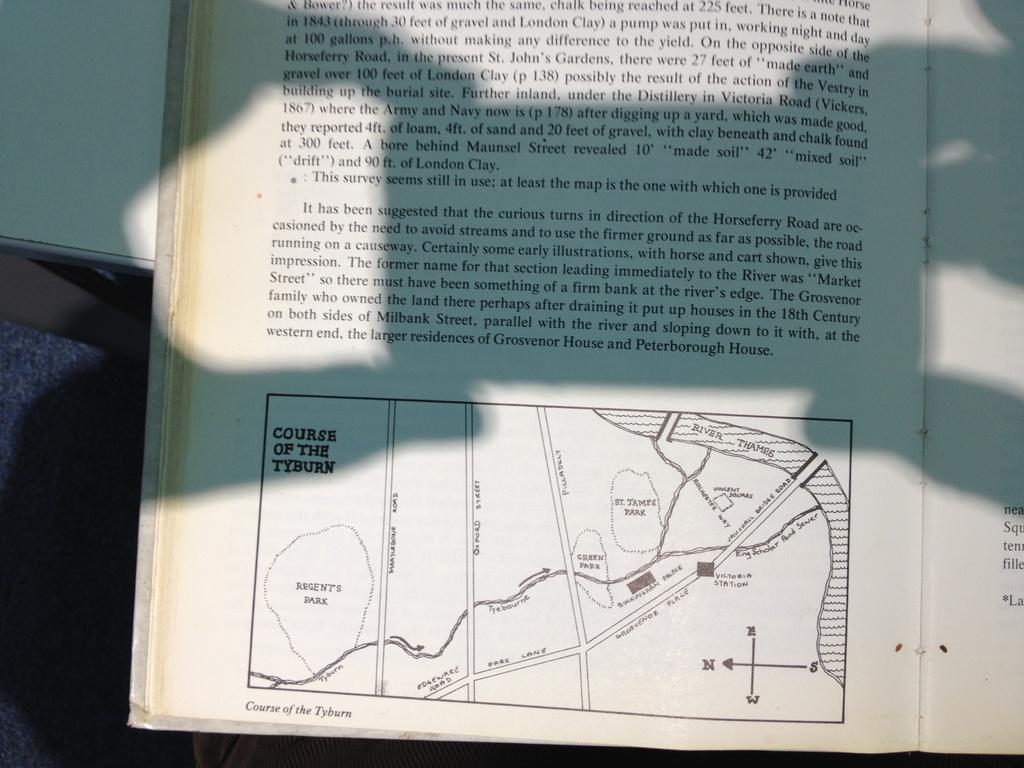What kind of course is shown?
Your answer should be very brief. Course of the tyburn. 